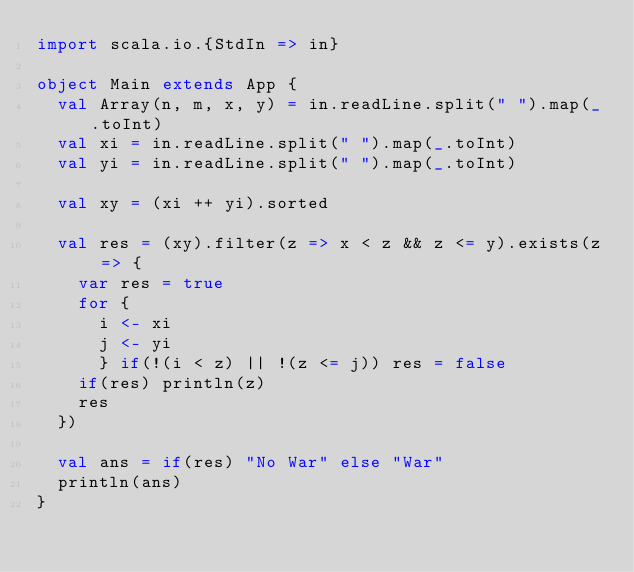Convert code to text. <code><loc_0><loc_0><loc_500><loc_500><_Scala_>import scala.io.{StdIn => in}

object Main extends App {
  val Array(n, m, x, y) = in.readLine.split(" ").map(_.toInt)
  val xi = in.readLine.split(" ").map(_.toInt)
  val yi = in.readLine.split(" ").map(_.toInt)

  val xy = (xi ++ yi).sorted

  val res = (xy).filter(z => x < z && z <= y).exists(z => {
    var res = true
    for {
      i <- xi
      j <- yi
      } if(!(i < z) || !(z <= j)) res = false
    if(res) println(z)
    res
  })

  val ans = if(res) "No War" else "War"
  println(ans)
}</code> 